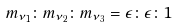Convert formula to latex. <formula><loc_0><loc_0><loc_500><loc_500>m _ { \nu _ { 1 } } \colon m _ { \nu _ { 2 } } \colon m _ { \nu _ { 3 } } = \epsilon \colon \epsilon \colon 1</formula> 